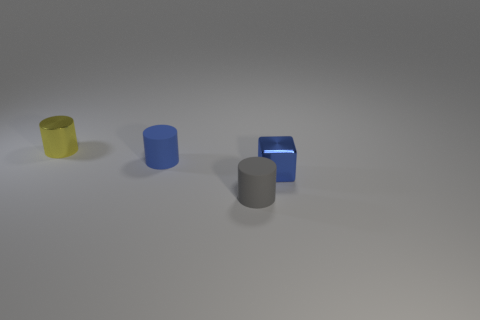What is the material of the tiny object that is both behind the small blue shiny block and in front of the small yellow metallic thing?
Ensure brevity in your answer.  Rubber. There is a gray cylinder; does it have the same size as the blue thing behind the shiny cube?
Provide a short and direct response. Yes. Are any blue cylinders visible?
Your answer should be very brief. Yes. There is a tiny gray thing that is the same shape as the yellow thing; what material is it?
Offer a very short reply. Rubber. There is a rubber thing that is in front of the tiny shiny thing that is right of the metal thing behind the blue block; how big is it?
Make the answer very short. Small. There is a small yellow shiny object; are there any small blue matte cylinders behind it?
Give a very brief answer. No. What is the size of the other thing that is the same material as the yellow object?
Your answer should be very brief. Small. How many metallic objects are the same shape as the blue rubber object?
Keep it short and to the point. 1. Is the material of the yellow cylinder the same as the blue object that is behind the tiny shiny cube?
Give a very brief answer. No. Are there more tiny objects that are left of the gray thing than tiny gray objects?
Make the answer very short. Yes. 